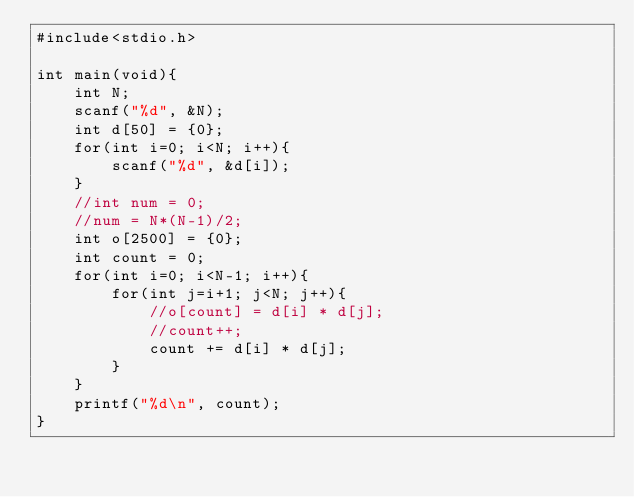<code> <loc_0><loc_0><loc_500><loc_500><_C_>#include<stdio.h>

int main(void){
    int N;
    scanf("%d", &N);
    int d[50] = {0};
    for(int i=0; i<N; i++){
        scanf("%d", &d[i]);
    }
    //int num = 0;
    //num = N*(N-1)/2;
    int o[2500] = {0};
    int count = 0;
    for(int i=0; i<N-1; i++){
        for(int j=i+1; j<N; j++){
            //o[count] = d[i] * d[j];
            //count++;
            count += d[i] * d[j];
        }
    }
    printf("%d\n", count);
}</code> 